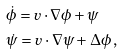Convert formula to latex. <formula><loc_0><loc_0><loc_500><loc_500>& \dot { \phi } = v \cdot \nabla \phi + \psi \\ & \dot { \psi } = v \cdot \nabla \psi + \Delta \phi \, , \\</formula> 